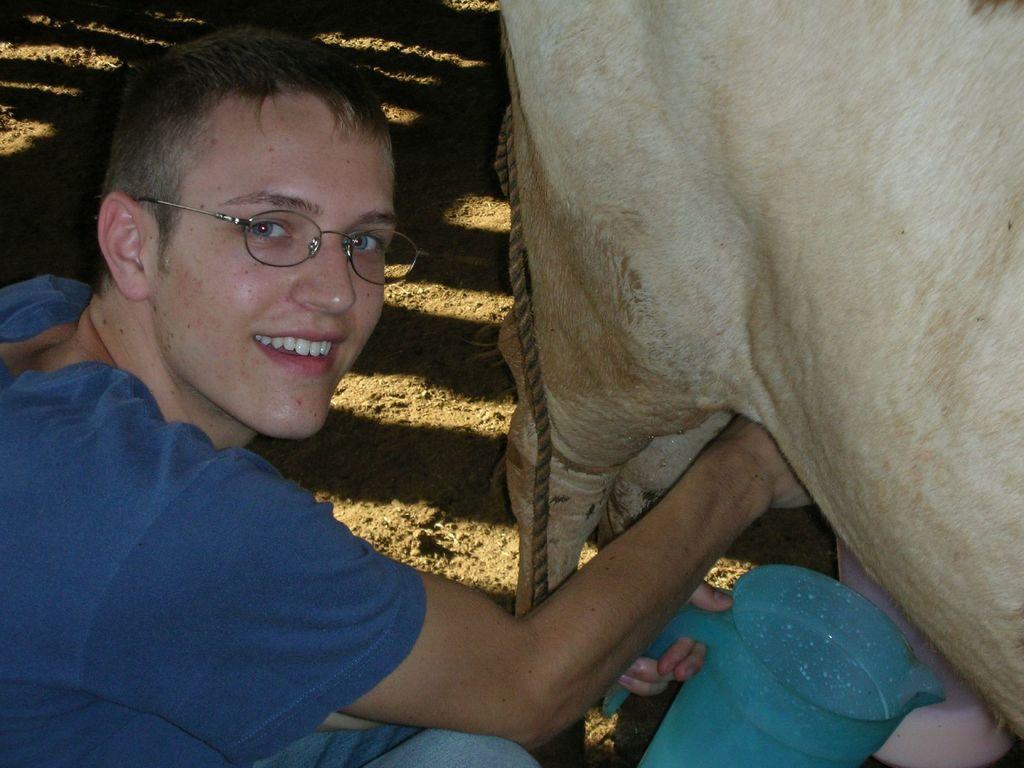Could you give a brief overview of what you see in this image? In this image we can see a man holding a jug in his hand. On the right side of the image we can see an animal and a container placed on the ground, we can also see a rope. 